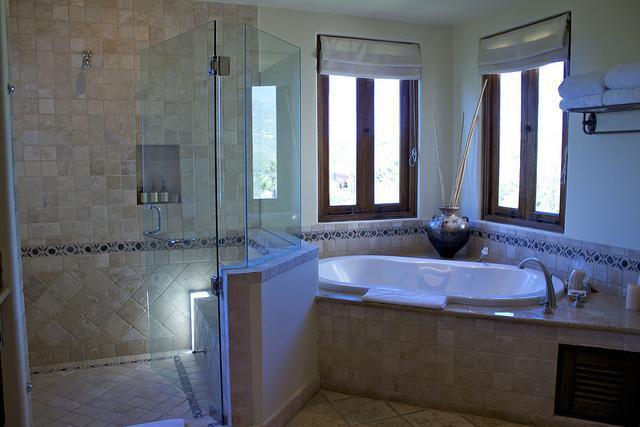How many windows are above the tub?
Give a very brief answer. 2. 